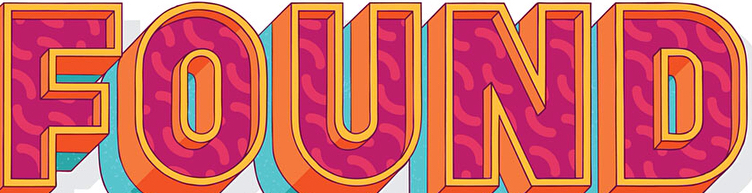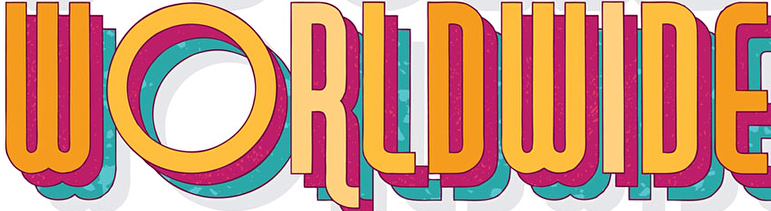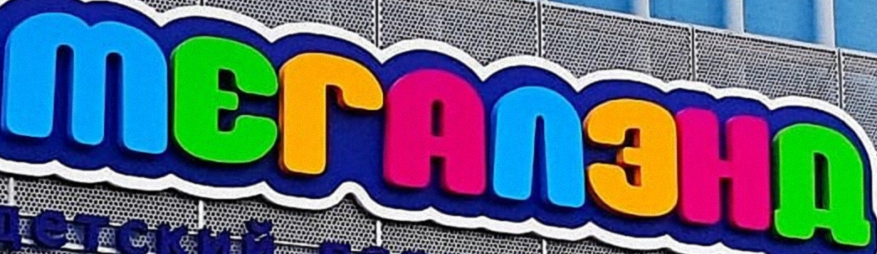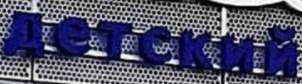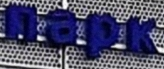What words are shown in these images in order, separated by a semicolon? FOUND; WORLDWIDE; MЕГAΛЗHД; детский; пapk 